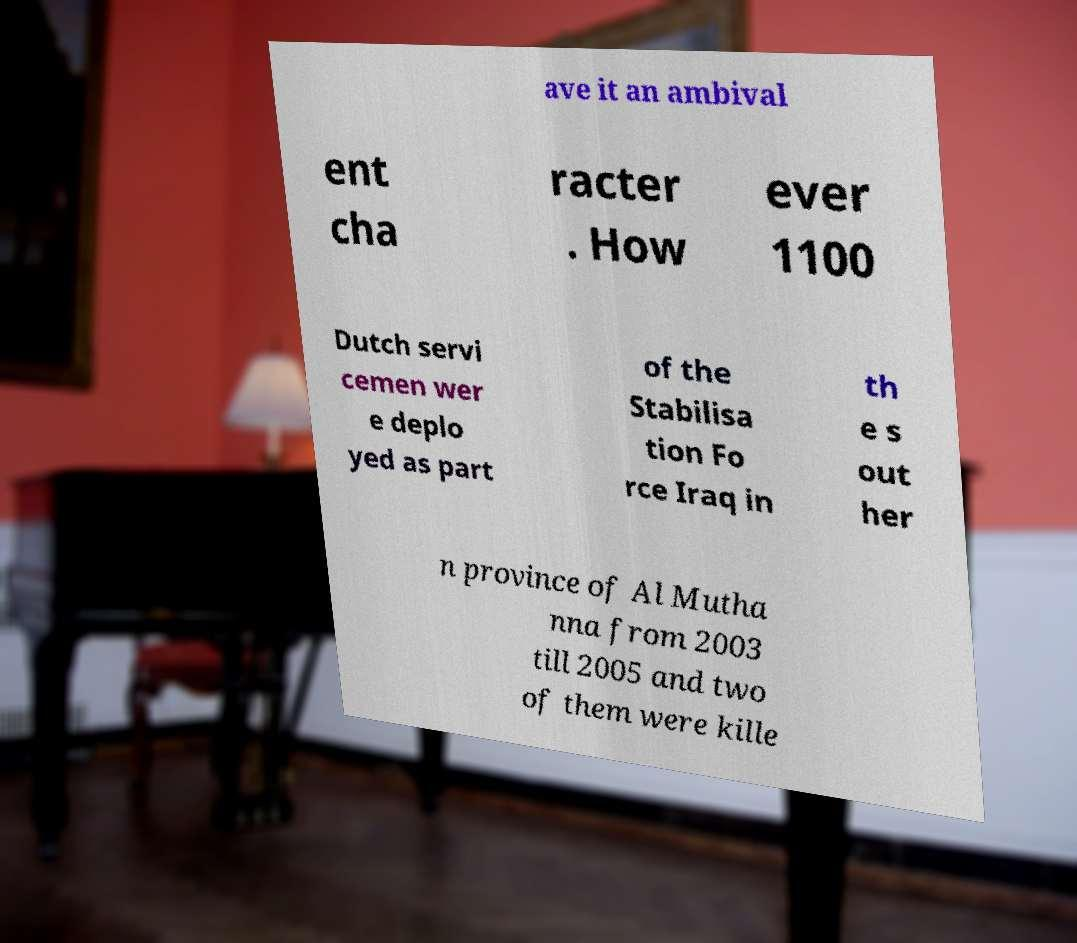For documentation purposes, I need the text within this image transcribed. Could you provide that? ave it an ambival ent cha racter . How ever 1100 Dutch servi cemen wer e deplo yed as part of the Stabilisa tion Fo rce Iraq in th e s out her n province of Al Mutha nna from 2003 till 2005 and two of them were kille 